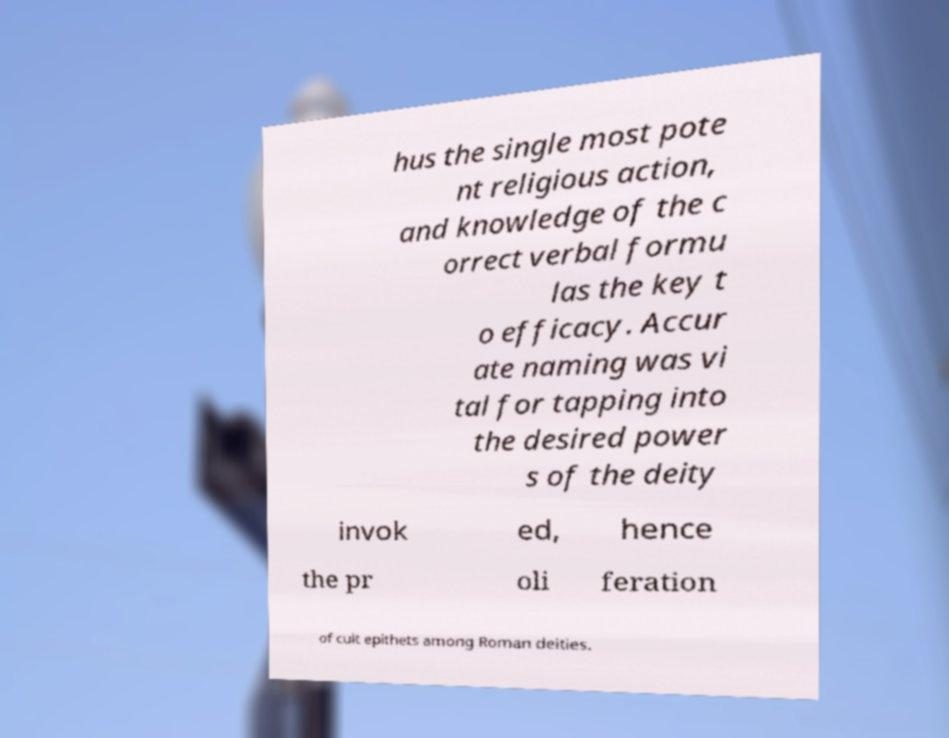I need the written content from this picture converted into text. Can you do that? hus the single most pote nt religious action, and knowledge of the c orrect verbal formu las the key t o efficacy. Accur ate naming was vi tal for tapping into the desired power s of the deity invok ed, hence the pr oli feration of cult epithets among Roman deities. 